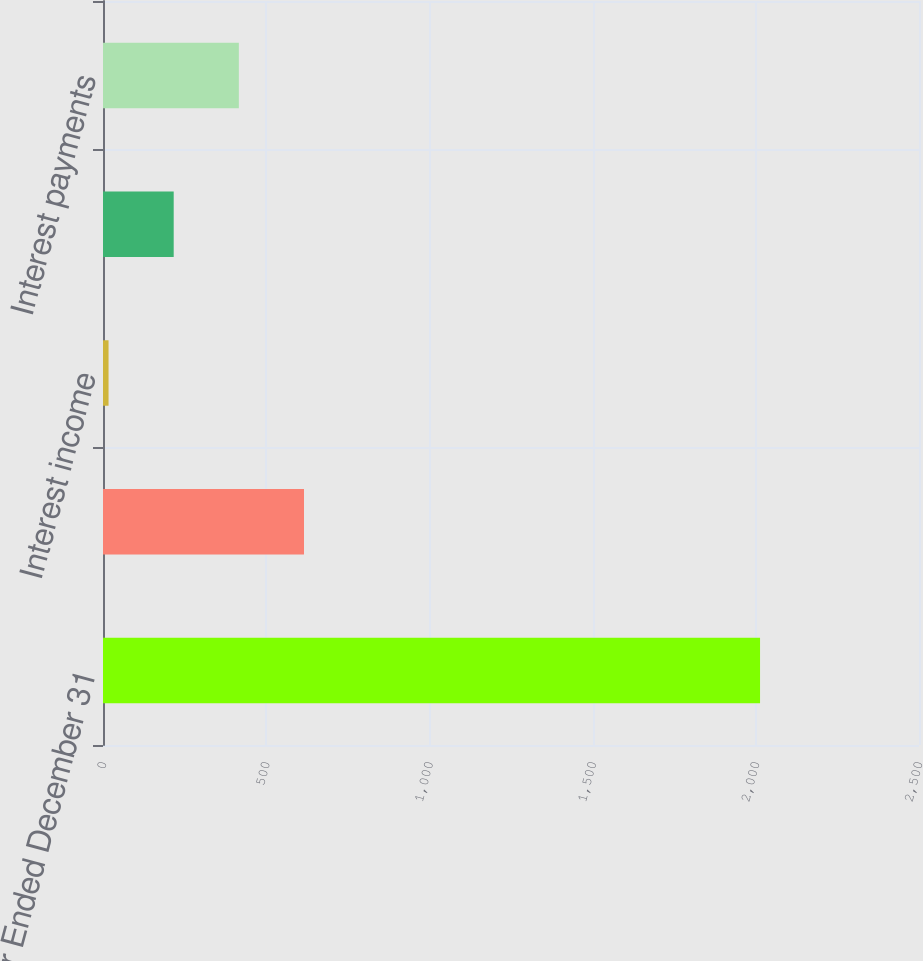<chart> <loc_0><loc_0><loc_500><loc_500><bar_chart><fcel>Year Ended December 31<fcel>Interest expense<fcel>Interest income<fcel>Interest expense net<fcel>Interest payments<nl><fcel>2013<fcel>615.8<fcel>17<fcel>216.6<fcel>416.2<nl></chart> 